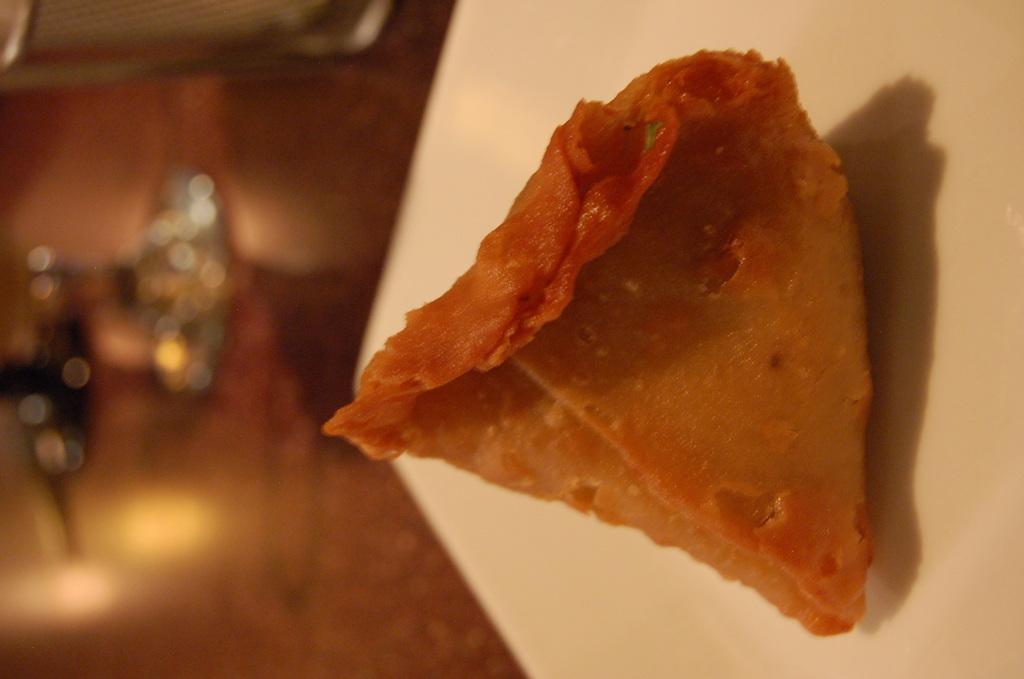Please provide a concise description of this image. In the image in the center we can see one white color plate. In plate we can see one samosa. 